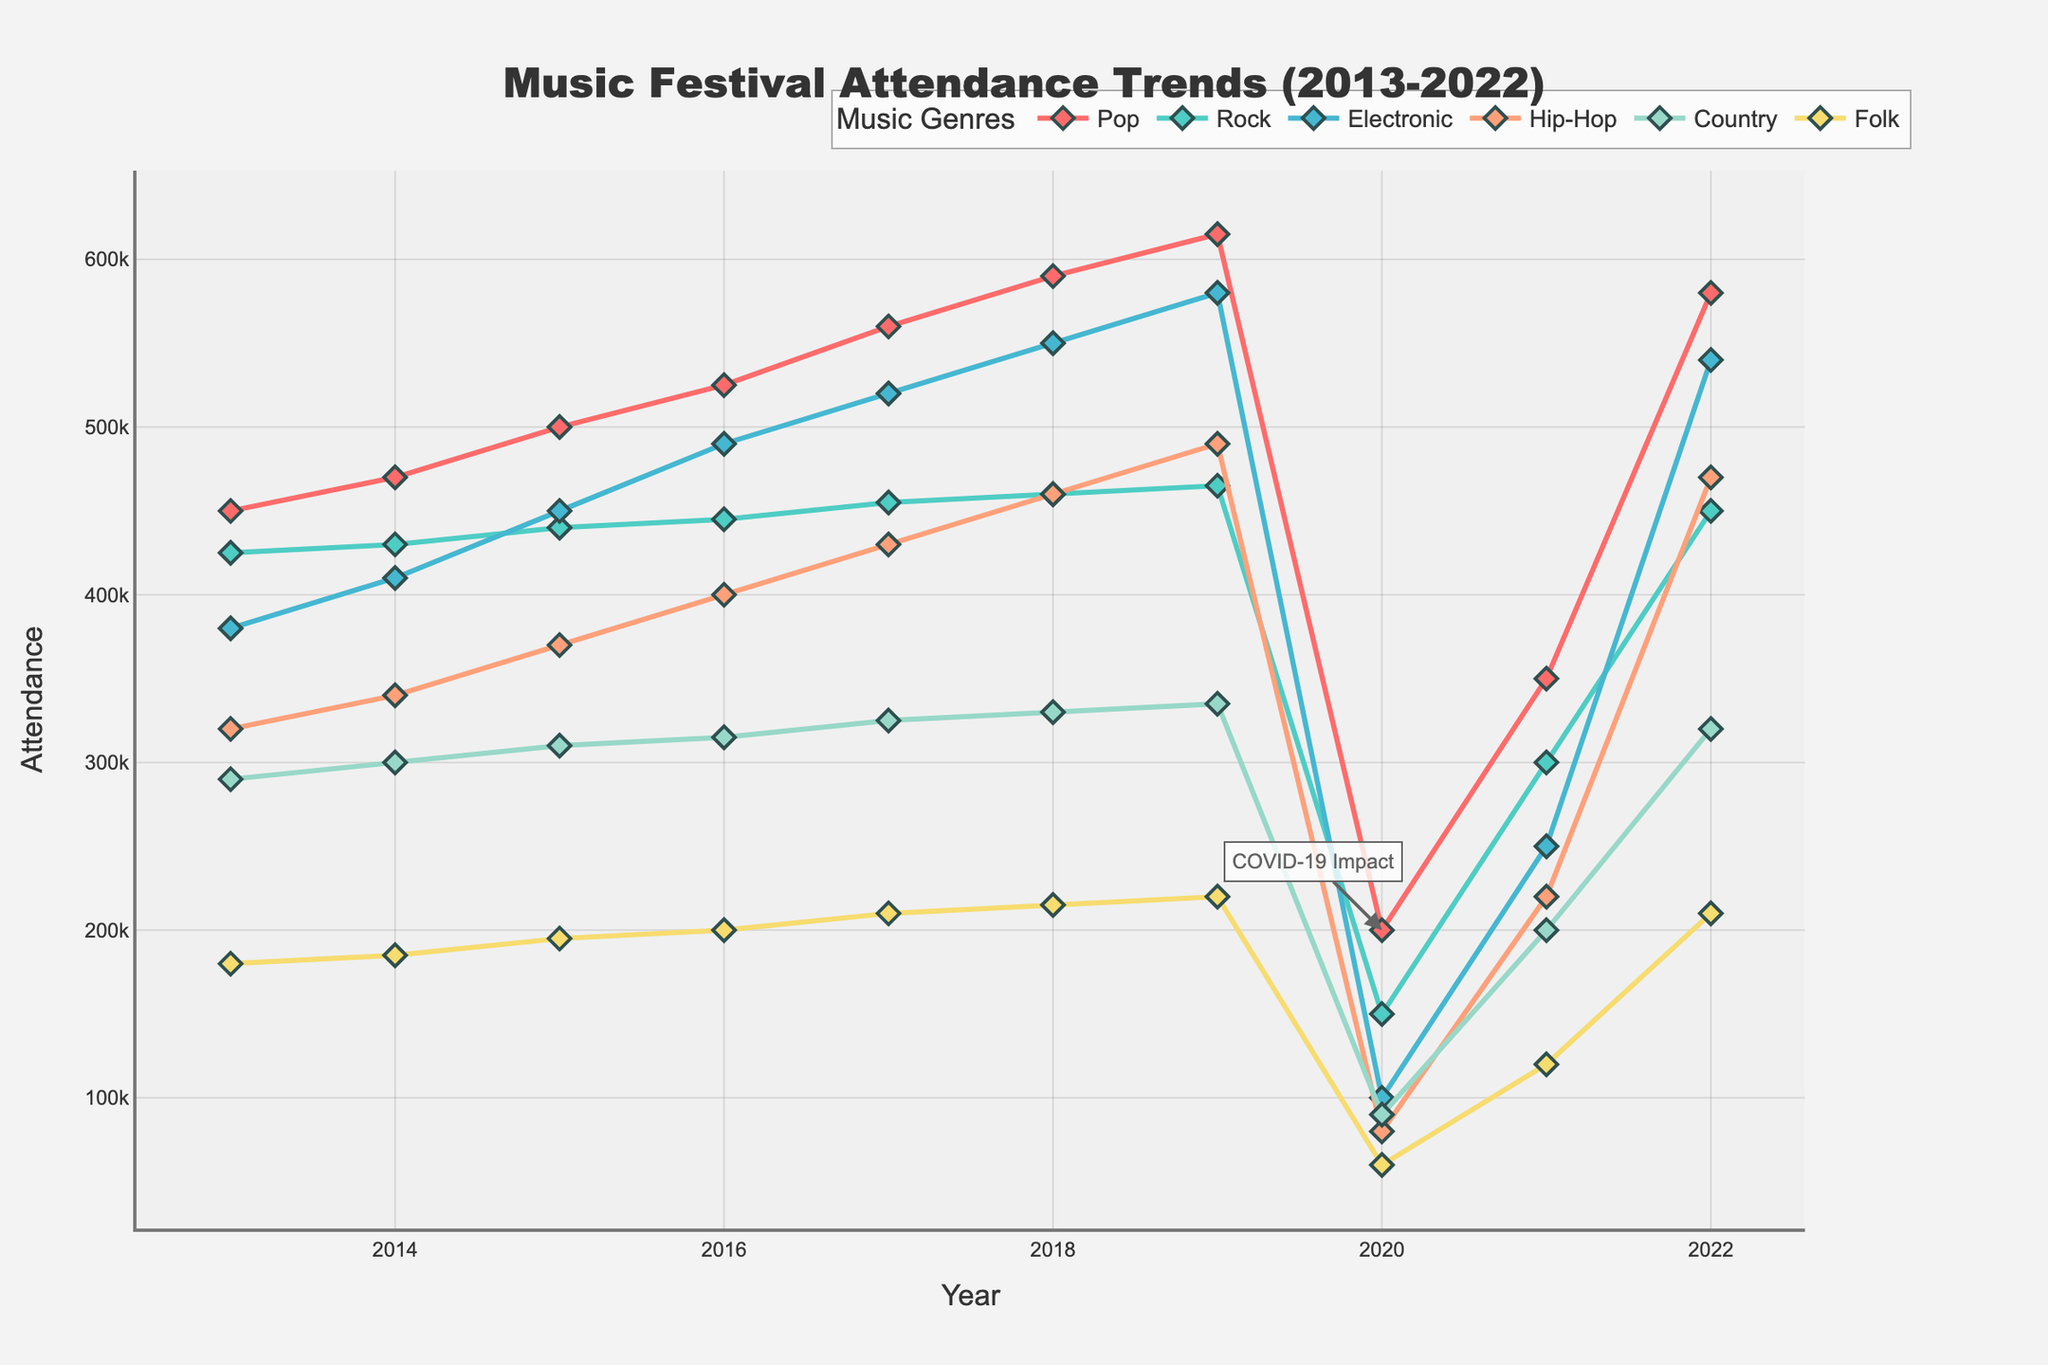What trend do you observe in the attendance for Pop music festivals from 2013 to 2022? From 2013 to 2019, the attendance for Pop music festivals shows a steady increase. However, there was a sharp decline in 2020 followed by a recovery in 2021 and nearly returning to pre-pandemic levels in 2022.
Answer: Steady increase, drop in 2020, recovery in 2021-2022 Which genre had the highest attendance in 2020? By looking at the year 2020 on the chart and comparing the attendance numbers for all genres, Country had the highest attendance.
Answer: Country How does the trend of Electronic music festival attendance compare to Hip-Hop from 2013 to 2019? From 2013 to 2019, both Electronic and Hip-Hop show a steady increase. However, Electronic music consistently had higher attendance than Hip-Hop every year in that range.
Answer: Electronic had higher and increasing attendance What is the difference in attendance between Folk and Rock festivals in 2016? The attendance for Folk in 2016 is 200,000, and for Rock, it is 445,000. The difference is obtained by subtracting Folk's attendance from Rock’s attendance.
Answer: 245,000 Which genre showed the least impact due to the COVID-19 pandemic in 2020, based on attendance drops? By comparing attendance drops from 2019 to 2020 for all genres, Folk showed the smallest decrease (from 220,000 in 2019 to 60,000 in 2020).
Answer: Folk What are the specific years where Pop and Rock attendance remains closer compared to other years? Visually examining the graph, Pop and Rock attendance remain closest in 2014 when their attendance was 470,000 and 430,000, respectively, and in 2022 when their attendance was 580,000 and 450,000, respectively.
Answer: 2014 and 2022 On average, how did the attendance for Hip-Hop music festivals change from 2013 to 2022? To find the average change, sum the attendance values for Hip-Hop for each year from 2013 to 2022 (320,000 + 340,000 + 370,000 + 400,000 + 430,000 + 460,000 + 490,000 + 80,000 + 220,000 + 470,000 = 3,580,000) and divide by the number of years (10).
Answer: 358,000 Compare the attendance for all genres in 2021 to their attendance in 2022. To compare, the attendance for each genre in 2021 and 2022 can be listed and subtracted (Pop: 350,000 to 580,000, Rock: 300,000 to 450,000, Electronic: 250,000 to 540,000, Hip-Hop: 220,000 to 470,000, Country: 200,000 to 320,000, Folk: 120,000 to 210,000). All genres saw significant increases in 2022.
Answer: All increased significantly By what percentage did Rock festival attendance change from 2019 to 2020? The attendance for Rock in 2019 was 465,000 and in 2020 was 150,000. The percentage change is calculated by ((150,000 - 465,000) / 465,000) * 100.
Answer: -67.74% What was the attendance difference between the highest and lowest attended genres in 2015? In 2015, the highest attendance was for Pop (500,000) and the lowest was for Folk (195,000). The difference is found by subtracting the lowest from the highest.
Answer: 305,000 